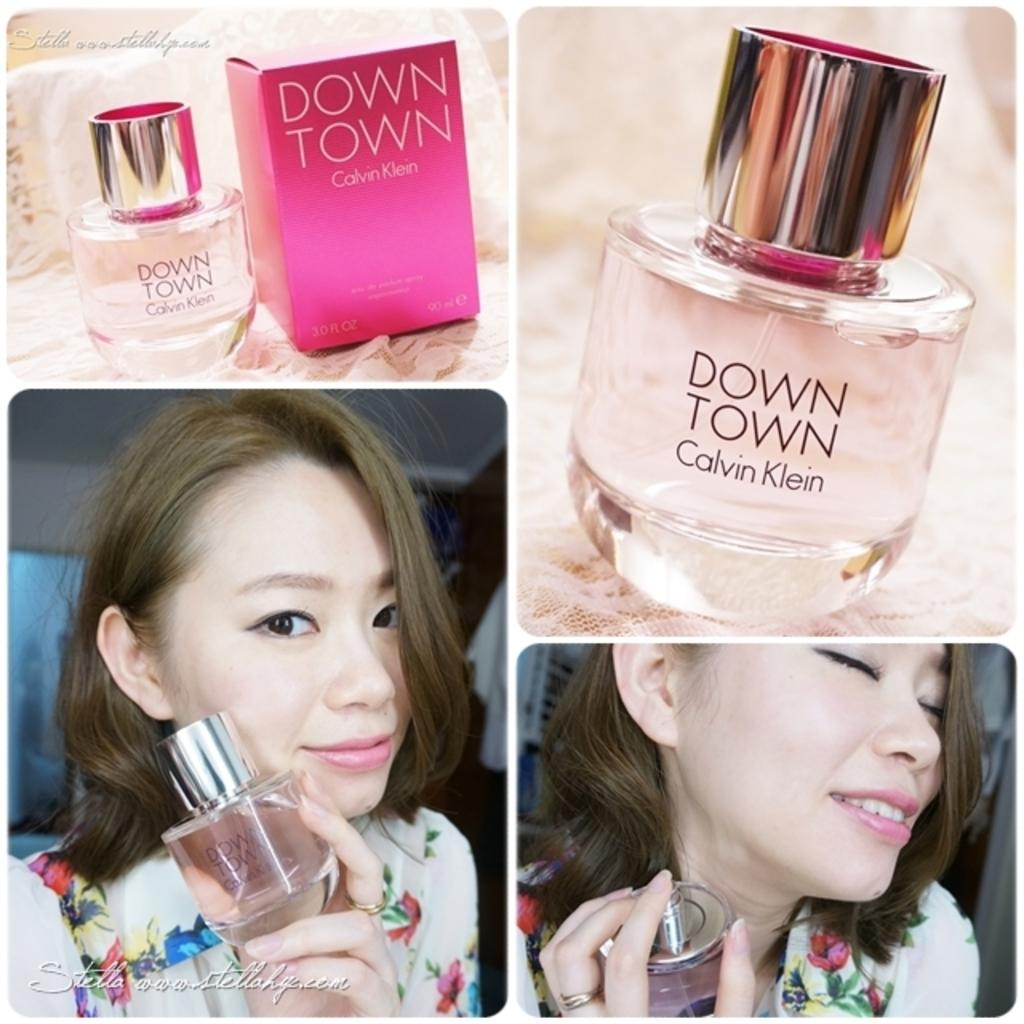Provide a one-sentence caption for the provided image. A woman poses with a bottle of Down Town perfume by Calvin Klein. 